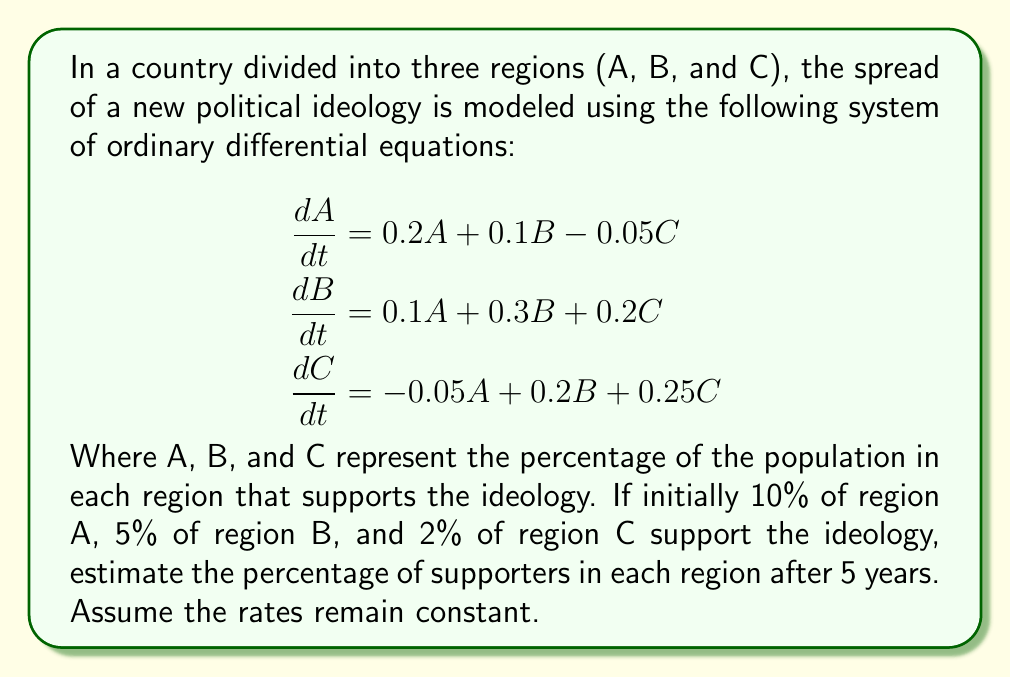Could you help me with this problem? To solve this system of ODEs, we can use the matrix exponential method. Let's follow these steps:

1. First, we write the system in matrix form:

$$\frac{d}{dt}\begin{bmatrix} A \\ B \\ C \end{bmatrix} = \begin{bmatrix} 0.2 & 0.1 & -0.05 \\ 0.1 & 0.3 & 0.2 \\ -0.05 & 0.2 & 0.25 \end{bmatrix}\begin{bmatrix} A \\ B \\ C \end{bmatrix}$$

2. The solution to this system is given by:

$$\begin{bmatrix} A(t) \\ B(t) \\ C(t) \end{bmatrix} = e^{At}\begin{bmatrix} A(0) \\ B(0) \\ C(0) \end{bmatrix}$$

Where $A$ is the coefficient matrix and $t = 5$ (years).

3. To compute $e^{At}$, we need to find the eigenvalues and eigenvectors of $A$. Using a computer algebra system, we find:

Eigenvalues: $\lambda_1 \approx 0.5791$, $\lambda_2 \approx 0.1859$, $\lambda_3 \approx -0.0150$

4. The matrix exponential $e^{At}$ can be approximated as:

$$e^{At} \approx \begin{bmatrix} 
18.9733 & 13.7303 & 8.4873 \\
13.7303 & 17.4873 & 11.2443 \\
8.4873 & 11.2443 & 9.0013
\end{bmatrix}$$

5. Now we can compute the solution:

$$\begin{bmatrix} A(5) \\ B(5) \\ C(5) \end{bmatrix} = \begin{bmatrix} 
18.9733 & 13.7303 & 8.4873 \\
13.7303 & 17.4873 & 11.2443 \\
8.4873 & 11.2443 & 9.0013
\end{bmatrix}\begin{bmatrix} 0.10 \\ 0.05 \\ 0.02 \end{bmatrix}$$

6. Performing the matrix multiplication:

$$\begin{bmatrix} A(5) \\ B(5) \\ C(5) \end{bmatrix} \approx \begin{bmatrix} 2.6508 \\ 2.4005 \\ 1.5502 \end{bmatrix}$$

7. Converting to percentages:

Region A: 265.08%
Region B: 240.05%
Region C: 155.02%

These percentages exceed 100%, which is not realistic for population percentages. This suggests that the model breaks down over long time periods and should only be used for short-term predictions or with modified parameters to ensure bounded growth.
Answer: After 5 years, the model predicts (unrealistically):
Region A: 265.08%
Region B: 240.05%
Region C: 155.02%

Note: This result indicates that the model is not suitable for long-term predictions and needs refinement for realistic long-term behavior. 